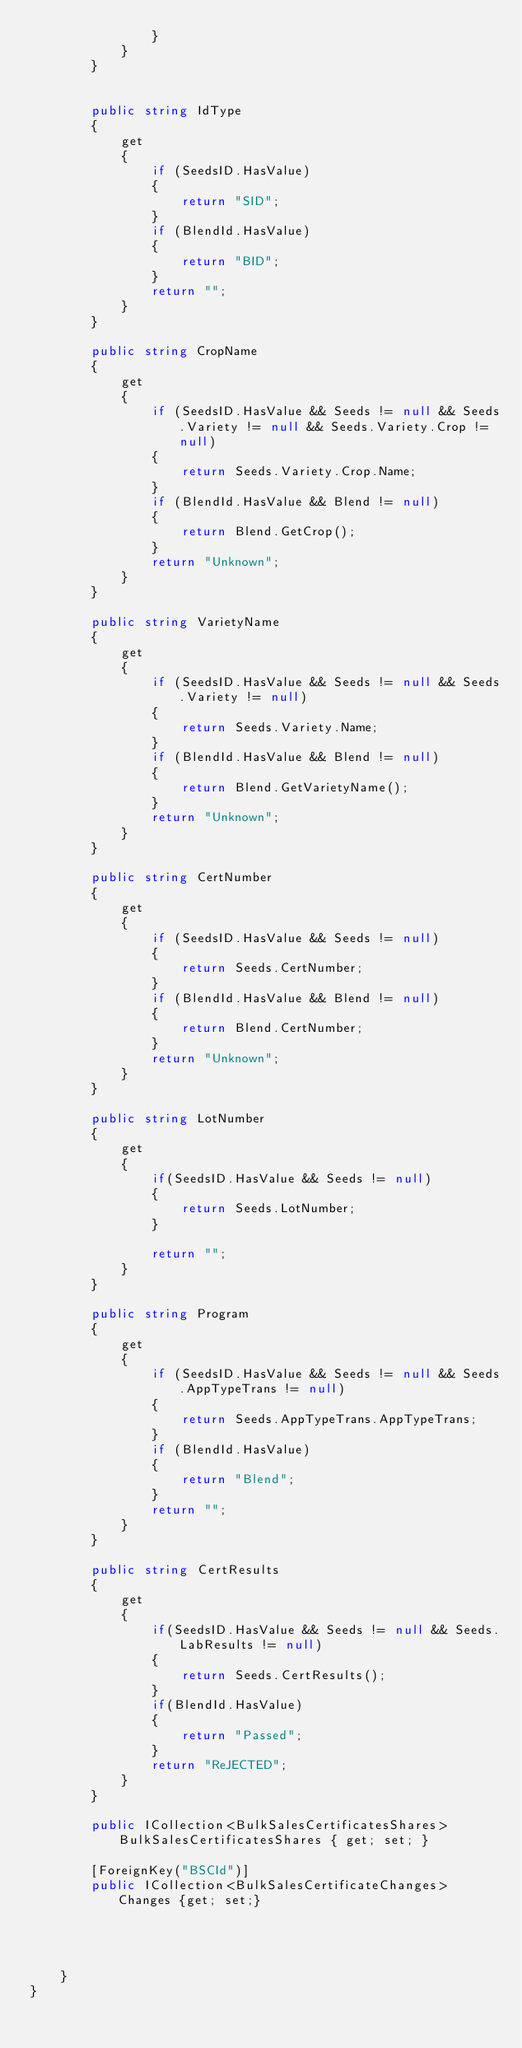Convert code to text. <code><loc_0><loc_0><loc_500><loc_500><_C#_>                }
            }
        }

        
        public string IdType
        {
            get
            {
                if (SeedsID.HasValue)
                {
                    return "SID";
                }
                if (BlendId.HasValue)
                {
                    return "BID";
                }
                return "";
            }
        }       

        public string CropName
        {
            get
            {
                if (SeedsID.HasValue && Seeds != null && Seeds.Variety != null && Seeds.Variety.Crop != null)
                {
                    return Seeds.Variety.Crop.Name;
                }
                if (BlendId.HasValue && Blend != null)
                {
                    return Blend.GetCrop();
                }                
                return "Unknown";
            }
        }

        public string VarietyName
        {
            get
            {
                if (SeedsID.HasValue && Seeds != null && Seeds.Variety != null)
                {
                    return Seeds.Variety.Name;
                }
                if (BlendId.HasValue && Blend != null)
                {
                    return Blend.GetVarietyName();
                }               
                return "Unknown";
            }
        }

        public string CertNumber
        {
            get
            {
                if (SeedsID.HasValue && Seeds != null)
                {
                    return Seeds.CertNumber;
                }
                if (BlendId.HasValue && Blend != null)
                {
                    return Blend.CertNumber;
                }                
                return "Unknown";
            }
        }

        public string LotNumber 
        { 
            get
            {
                if(SeedsID.HasValue && Seeds != null)
                {
                    return Seeds.LotNumber;
                }

                return "";
            }
        }

        public string Program 
        { 
            get
            {
                if (SeedsID.HasValue && Seeds != null && Seeds.AppTypeTrans != null)
                {
                    return Seeds.AppTypeTrans.AppTypeTrans;
                }
                if (BlendId.HasValue)
                {
                    return "Blend";
                }
                return "";
            }
        }

        public string CertResults
        {
            get
            {
                if(SeedsID.HasValue && Seeds != null && Seeds.LabResults != null)
                {
                    return Seeds.CertResults();
                }
                if(BlendId.HasValue)
                {
                    return "Passed";
                }
                return "ReJECTED";
            }
        }

        public ICollection<BulkSalesCertificatesShares> BulkSalesCertificatesShares { get; set; }

        [ForeignKey("BSCId")]
        public ICollection<BulkSalesCertificateChanges> Changes {get; set;}

              


    }
}
</code> 